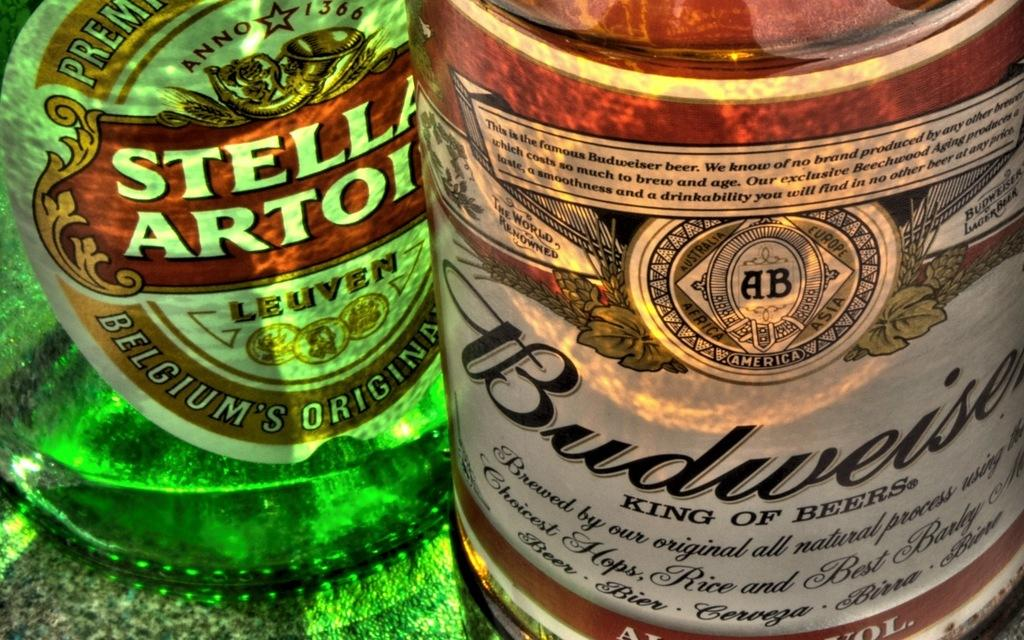<image>
Share a concise interpretation of the image provided. The king of beer sits beside Belgium Original beer. 